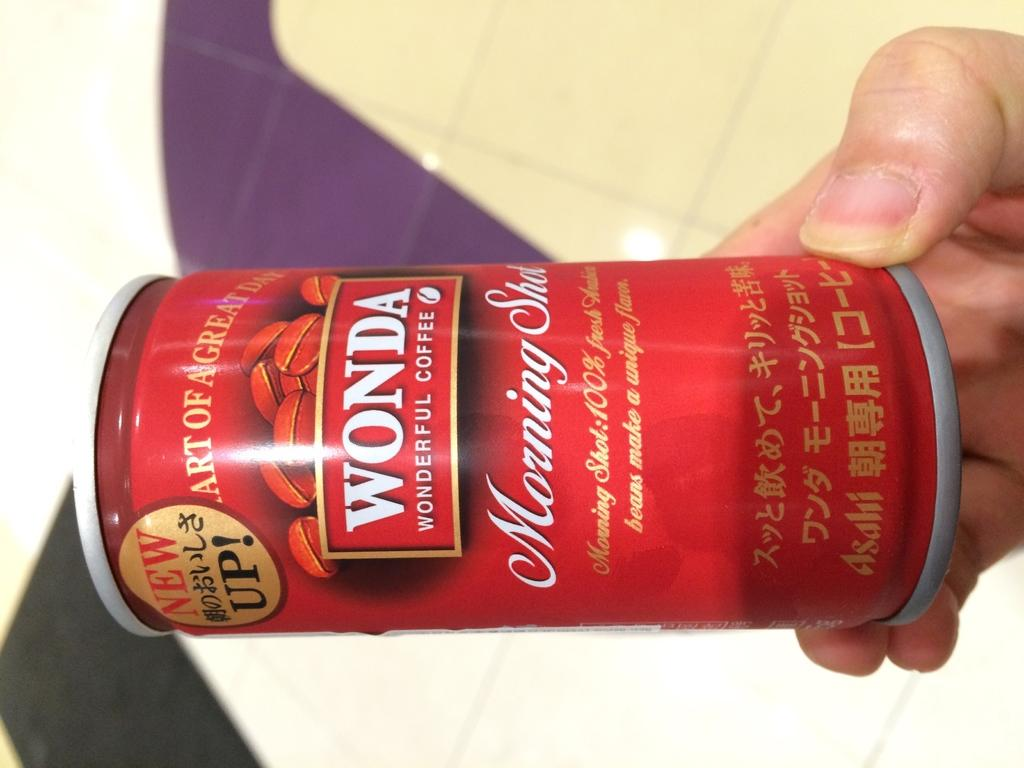<image>
Relay a brief, clear account of the picture shown. A hand holds a red can of Wonda Coffee. 